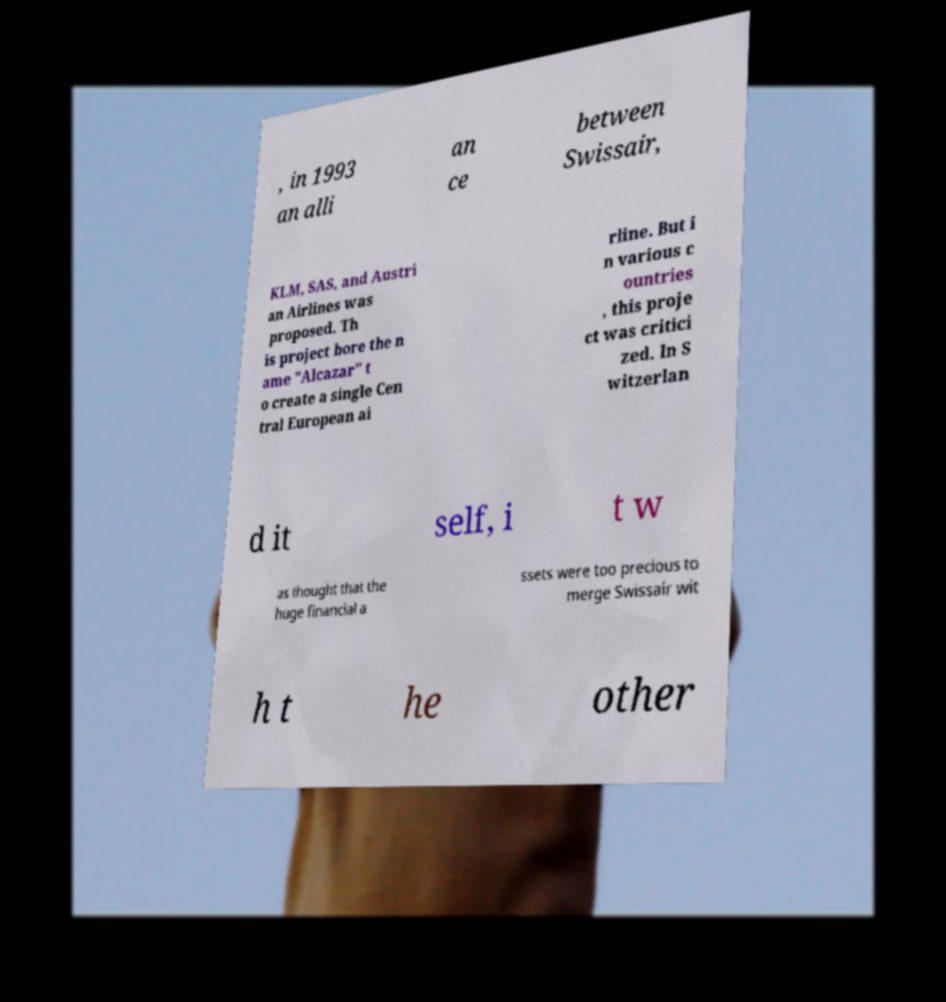Can you read and provide the text displayed in the image?This photo seems to have some interesting text. Can you extract and type it out for me? , in 1993 an alli an ce between Swissair, KLM, SAS, and Austri an Airlines was proposed. Th is project bore the n ame "Alcazar" t o create a single Cen tral European ai rline. But i n various c ountries , this proje ct was critici zed. In S witzerlan d it self, i t w as thought that the huge financial a ssets were too precious to merge Swissair wit h t he other 